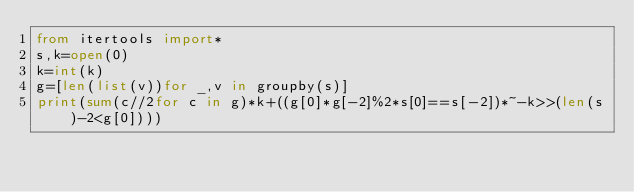<code> <loc_0><loc_0><loc_500><loc_500><_Python_>from itertools import*
s,k=open(0)
k=int(k)
g=[len(list(v))for _,v in groupby(s)]
print(sum(c//2for c in g)*k+((g[0]*g[-2]%2*s[0]==s[-2])*~-k>>(len(s)-2<g[0])))</code> 